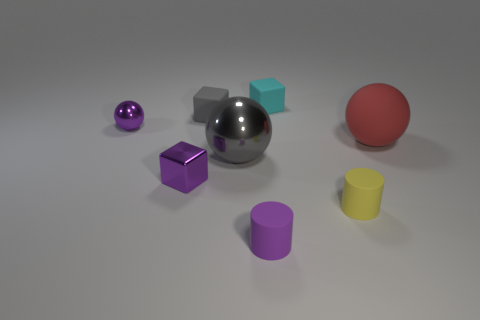Subtract all metal balls. How many balls are left? 1 Add 1 tiny cyan cubes. How many objects exist? 9 Subtract all purple cylinders. How many cylinders are left? 1 Subtract all balls. How many objects are left? 5 Subtract 2 cubes. How many cubes are left? 1 Add 6 tiny cyan shiny cylinders. How many tiny cyan shiny cylinders exist? 6 Subtract 0 blue cylinders. How many objects are left? 8 Subtract all green blocks. Subtract all green spheres. How many blocks are left? 3 Subtract all tiny purple metal things. Subtract all cyan objects. How many objects are left? 5 Add 7 small purple shiny things. How many small purple shiny things are left? 9 